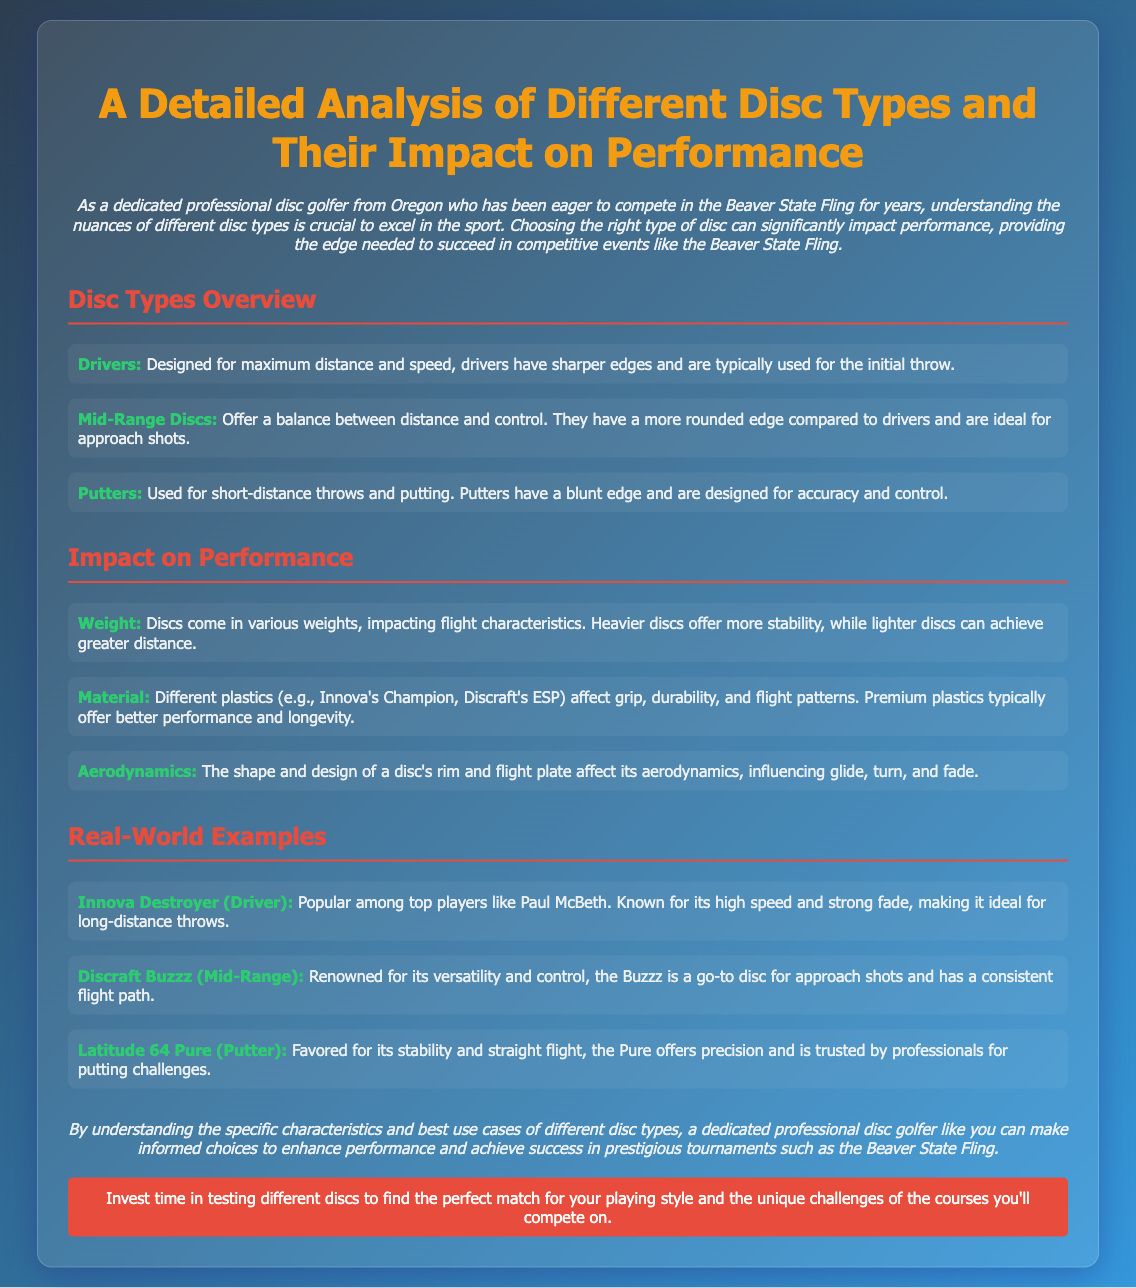what type of disc is designed for maximum distance and speed? The document states that drivers are designed for maximum distance and speed.
Answer: Drivers what is the popular mid-range disc mentioned in the document? The document mentions Discraft Buzzz as a renowned mid-range disc.
Answer: Discraft Buzzz what type of plastic is known for better performance and longevity? The document indicates that premium plastics typically offer better performance and longevity.
Answer: Premium plastics who is favored for using Latitude 64 Pure? According to the document, Latitude 64 Pure is trusted by professionals for putting challenges.
Answer: Professionals how are heavier discs described in relation to distance? The document describes heavier discs as offering more stability, while lighter discs can achieve greater distance.
Answer: More stability what is the conclusion about understanding different disc types? The conclusion suggests that understanding the specific characteristics of different disc types helps enhance performance.
Answer: Enhance performance which driver is popular among top players? The document states that Innova Destroyer is popular among top players like Paul McBeth.
Answer: Innova Destroyer what is the ideal use for mid-range discs according to the document? The document states that mid-range discs are ideal for approach shots.
Answer: Approach shots what is the impact of a disc's aerodynamics? The document explains that the shape and design of a disc's rim and flight plate affect glide, turn, and fade.
Answer: Glide, turn, and fade what should a dedicated professional disc golfer invest time in according to the document? The document advises investing time in testing different discs to find the perfect match for playing style.
Answer: Testing different discs 